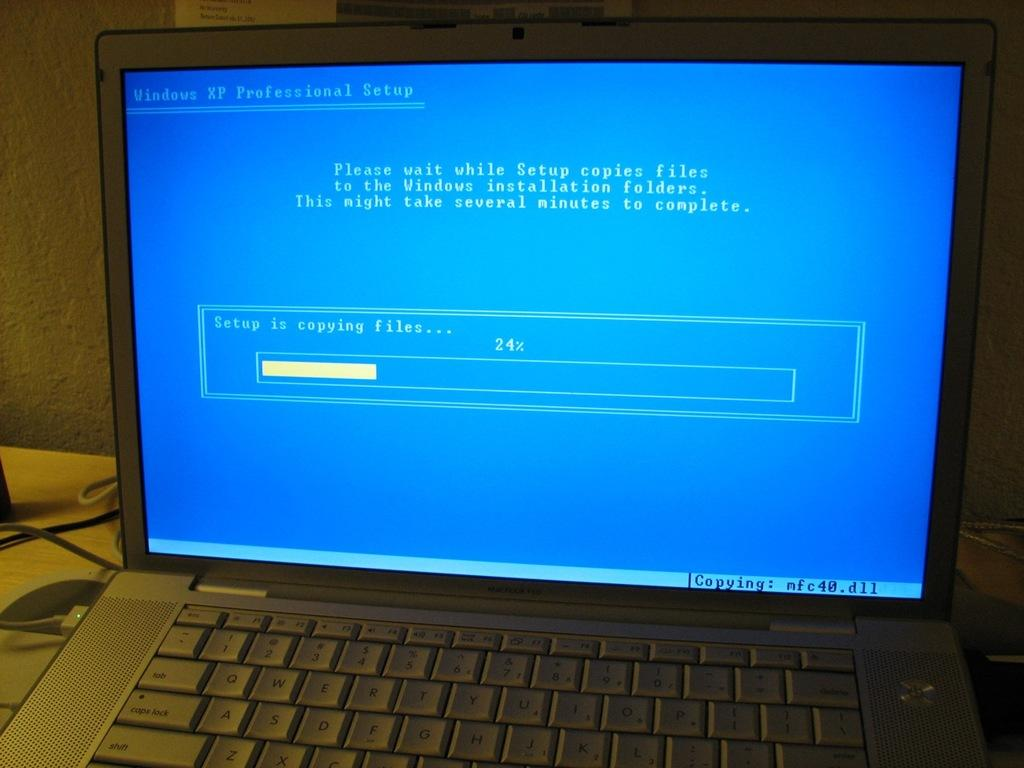<image>
Offer a succinct explanation of the picture presented. A monitor with Windows XP Professional setup at the top. 